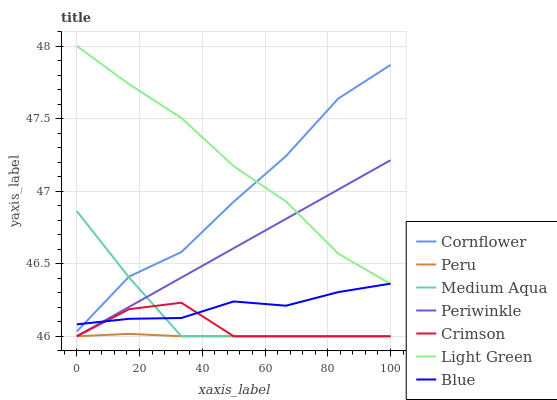Does Peru have the minimum area under the curve?
Answer yes or no. Yes. Does Light Green have the maximum area under the curve?
Answer yes or no. Yes. Does Cornflower have the minimum area under the curve?
Answer yes or no. No. Does Cornflower have the maximum area under the curve?
Answer yes or no. No. Is Periwinkle the smoothest?
Answer yes or no. Yes. Is Cornflower the roughest?
Answer yes or no. Yes. Is Peru the smoothest?
Answer yes or no. No. Is Peru the roughest?
Answer yes or no. No. Does Peru have the lowest value?
Answer yes or no. Yes. Does Cornflower have the lowest value?
Answer yes or no. No. Does Light Green have the highest value?
Answer yes or no. Yes. Does Cornflower have the highest value?
Answer yes or no. No. Is Medium Aqua less than Light Green?
Answer yes or no. Yes. Is Light Green greater than Crimson?
Answer yes or no. Yes. Does Peru intersect Medium Aqua?
Answer yes or no. Yes. Is Peru less than Medium Aqua?
Answer yes or no. No. Is Peru greater than Medium Aqua?
Answer yes or no. No. Does Medium Aqua intersect Light Green?
Answer yes or no. No. 